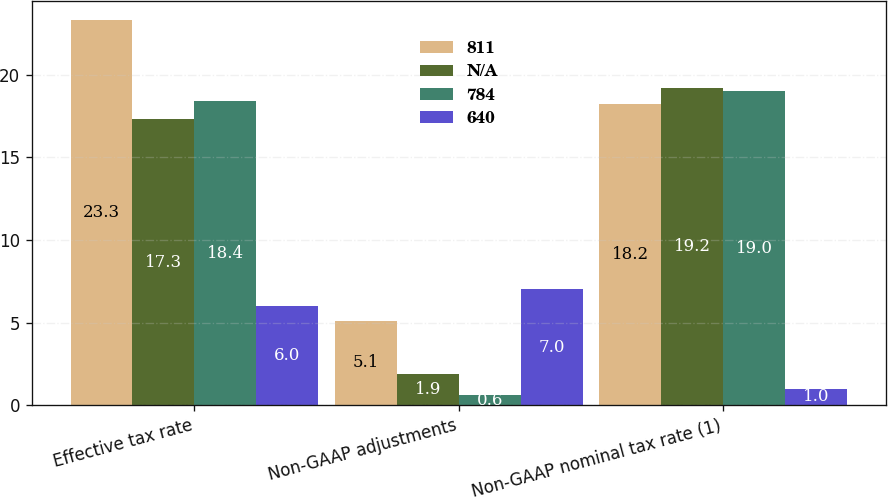<chart> <loc_0><loc_0><loc_500><loc_500><stacked_bar_chart><ecel><fcel>Effective tax rate<fcel>Non-GAAP adjustments<fcel>Non-GAAP nominal tax rate (1)<nl><fcel>811<fcel>23.3<fcel>5.1<fcel>18.2<nl><fcel>nan<fcel>17.3<fcel>1.9<fcel>19.2<nl><fcel>784<fcel>18.4<fcel>0.6<fcel>19<nl><fcel>640<fcel>6<fcel>7<fcel>1<nl></chart> 